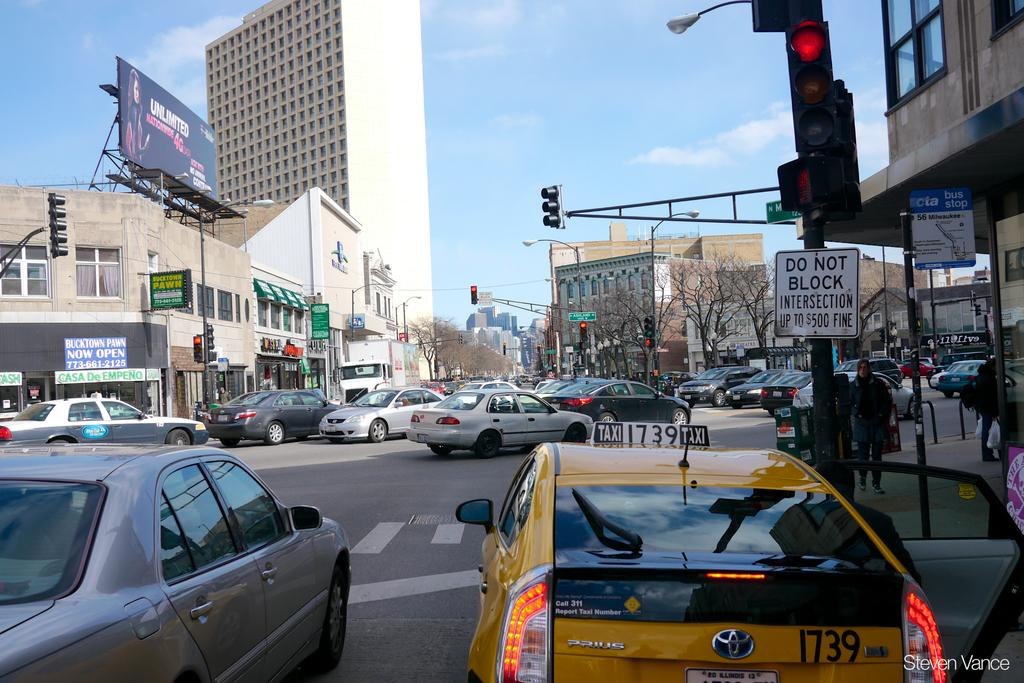<image>
Give a short and clear explanation of the subsequent image. A billboard above a pawn store says unlimited. 